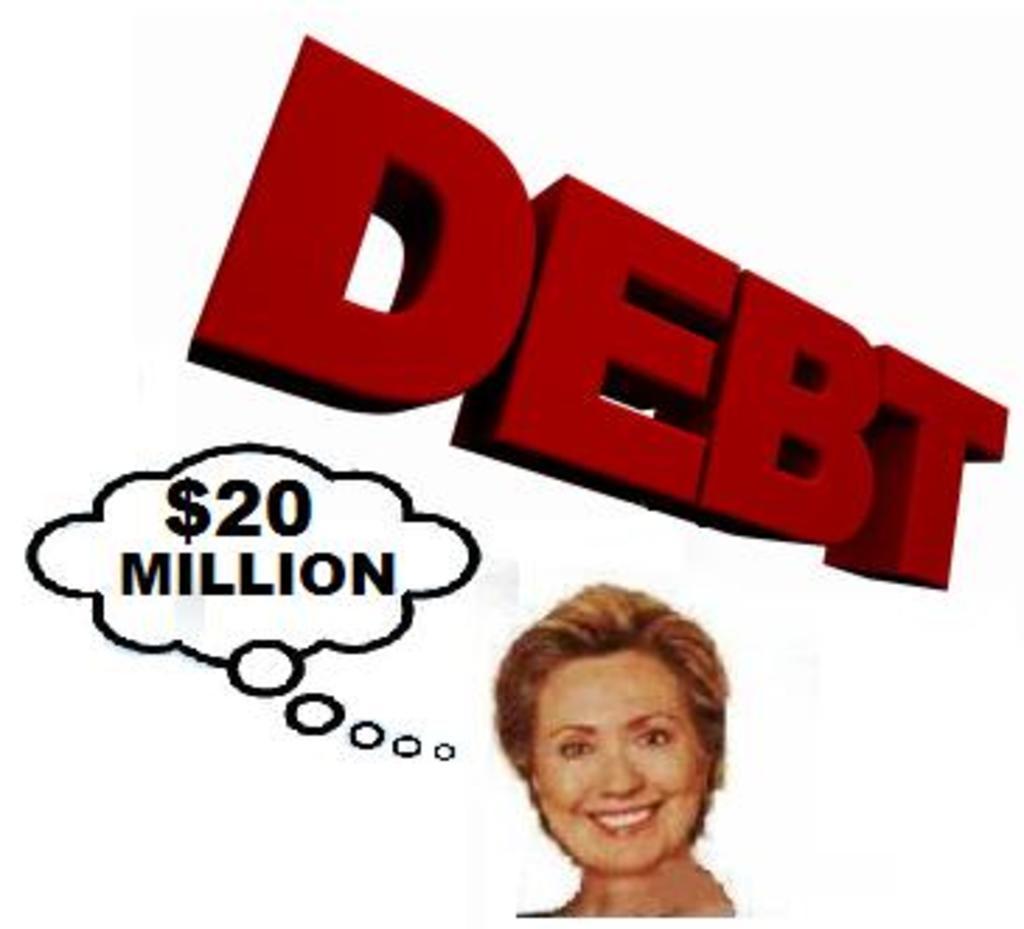Please provide a concise description of this image. This is a poster at the bottom there is one person, and in the center there is some text. 